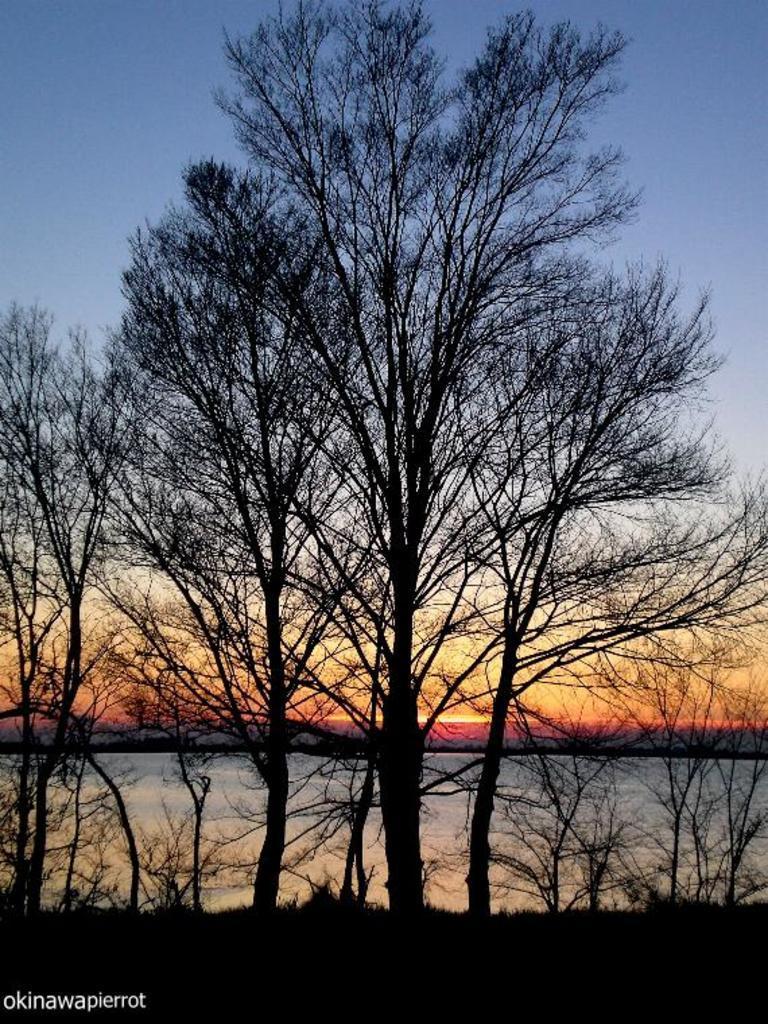In one or two sentences, can you explain what this image depicts? In this image, we can see so many trees. Background there is a sky. At the bottom of the image, we can see a watermark. 